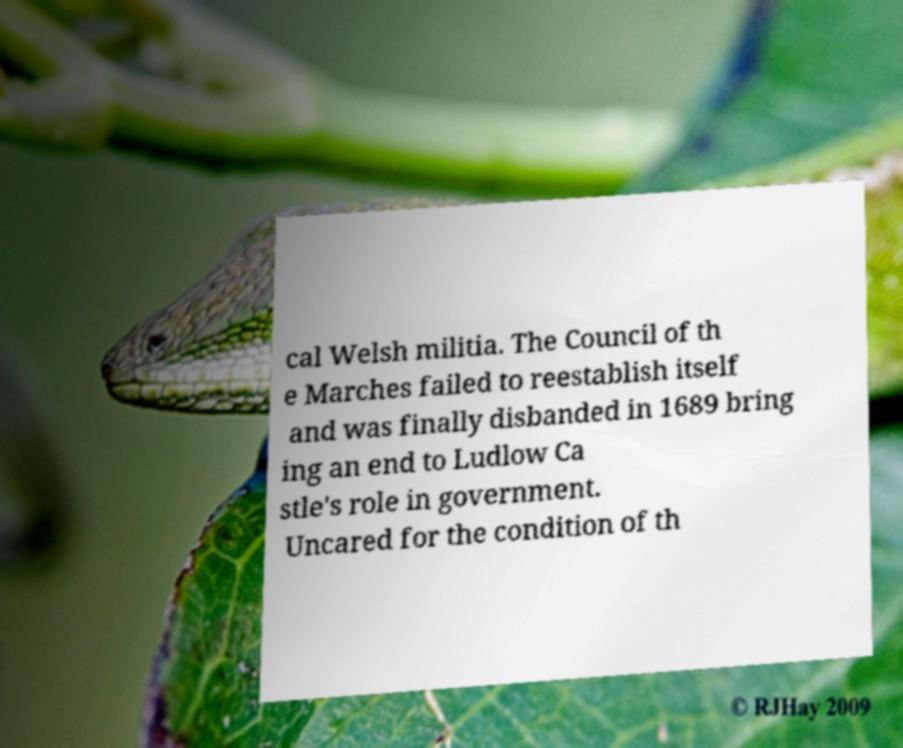What messages or text are displayed in this image? I need them in a readable, typed format. cal Welsh militia. The Council of th e Marches failed to reestablish itself and was finally disbanded in 1689 bring ing an end to Ludlow Ca stle's role in government. Uncared for the condition of th 